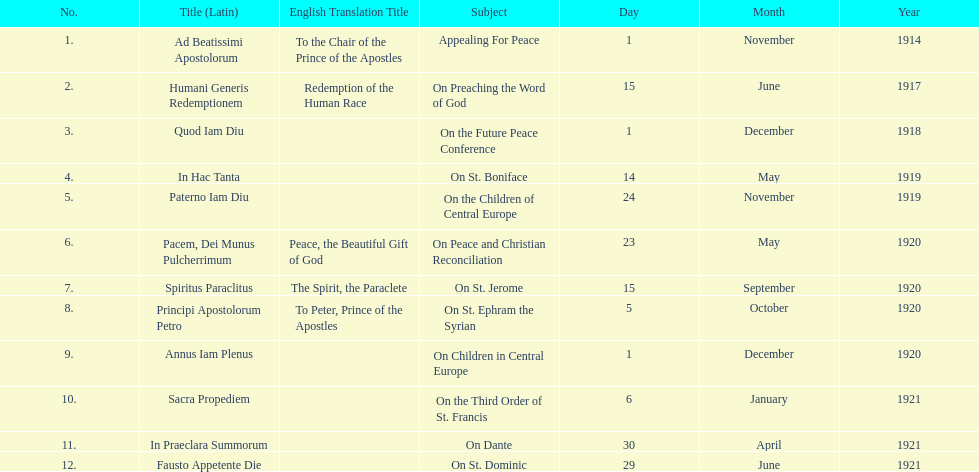How long after quod iam diu was paterno iam diu issued? 11 months. 